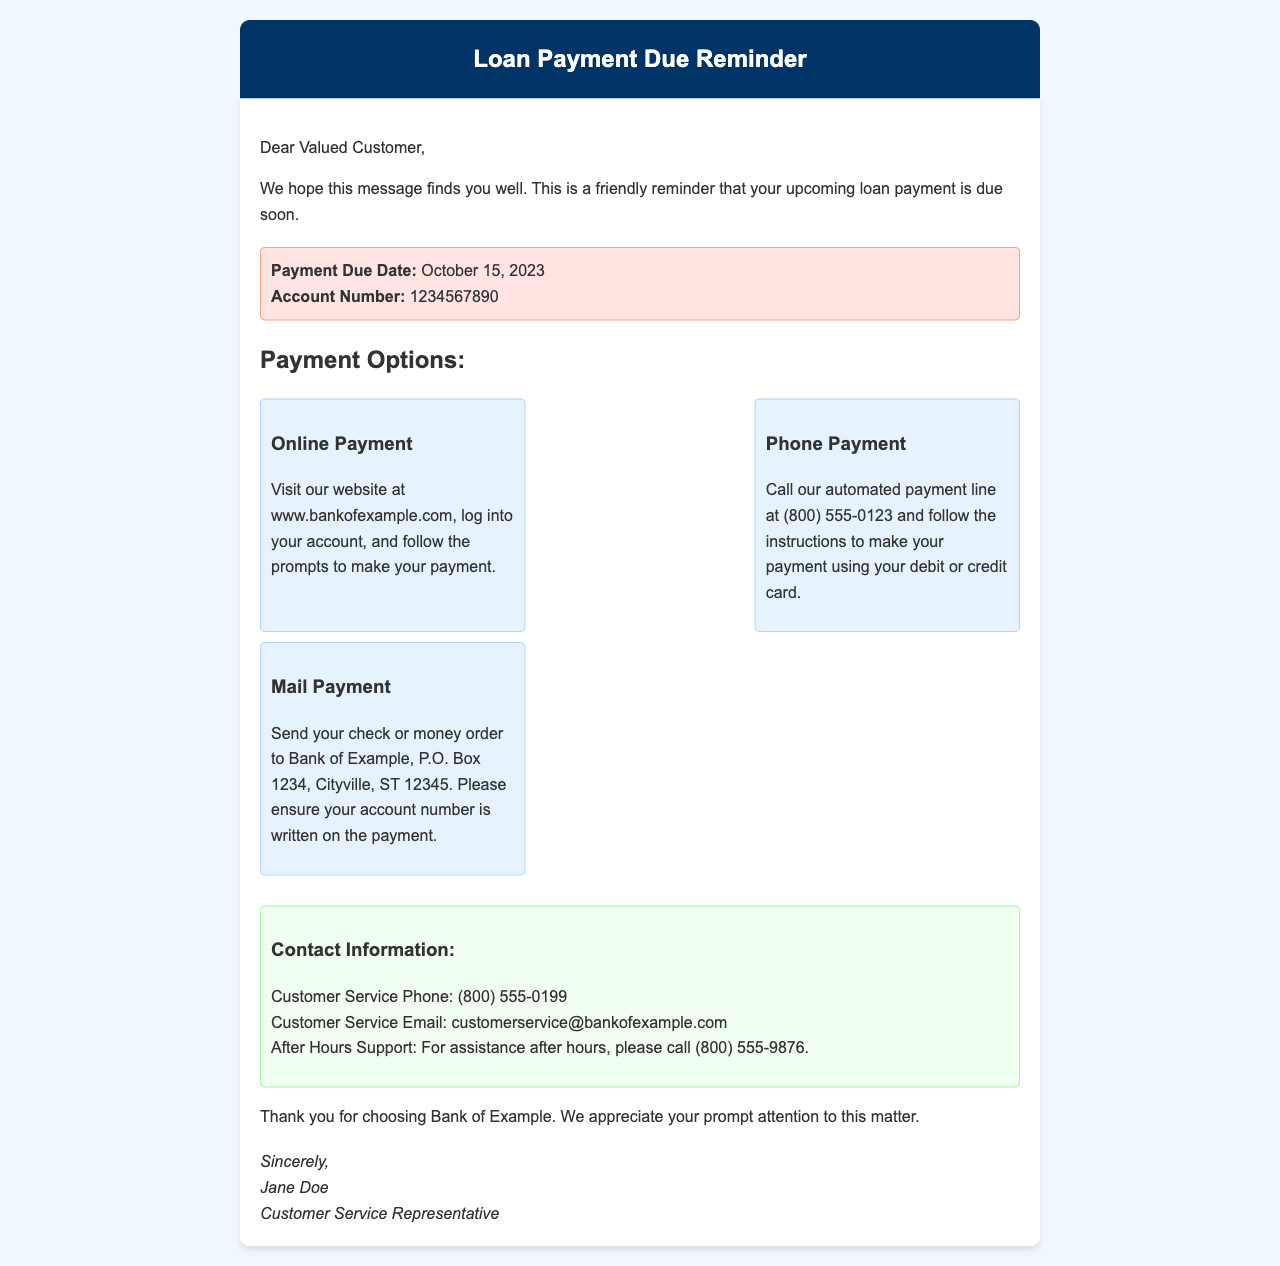What is the due date for the loan payment? The due date for the loan payment is explicitly mentioned in the document as October 15, 2023.
Answer: October 15, 2023 What is the account number referenced in the letter? The account number is provided in the due date section of the document as 1234567890.
Answer: 1234567890 How can I make an online payment? The instructions for making an online payment are outlined in the payment options section, directing customers to visit the bank's website.
Answer: Visit the website What number do I call for after-hours support? The contact information section lists the after-hours support phone number as (800) 555-9876.
Answer: (800) 555-9876 Who signed the letter? The closing signature of the letter identifies Jane Doe as the Customer Service Representative.
Answer: Jane Doe What type of payment option involves sending a check? The payment options section details the mail payment option, which involves sending a check or money order.
Answer: Mail Payment How many payment options are provided in the document? The content specifies three distinct payment options available to the customer.
Answer: Three What is the customer service email address? The contact information section provides the customer service email as customerservice@bankofexample.com.
Answer: customerservice@bankofexample.com 